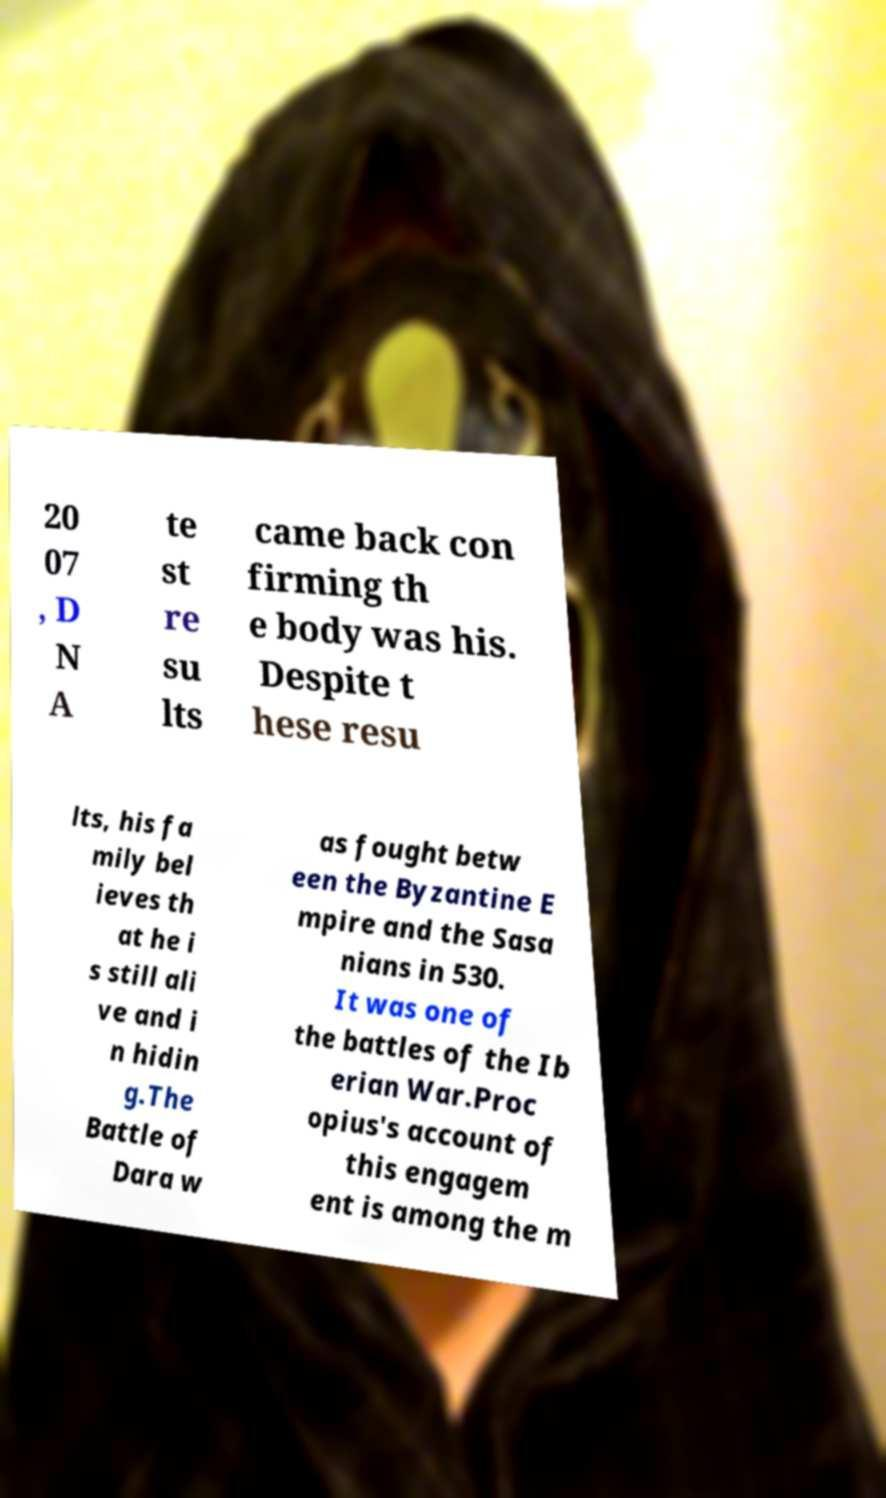Can you read and provide the text displayed in the image?This photo seems to have some interesting text. Can you extract and type it out for me? 20 07 , D N A te st re su lts came back con firming th e body was his. Despite t hese resu lts, his fa mily bel ieves th at he i s still ali ve and i n hidin g.The Battle of Dara w as fought betw een the Byzantine E mpire and the Sasa nians in 530. It was one of the battles of the Ib erian War.Proc opius's account of this engagem ent is among the m 